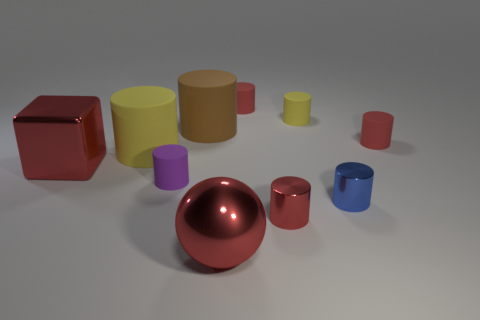How many red cylinders must be subtracted to get 1 red cylinders? 2 Subtract all blue spheres. How many red cylinders are left? 3 Subtract 2 cylinders. How many cylinders are left? 6 Subtract all brown cylinders. How many cylinders are left? 7 Subtract all red rubber cylinders. How many cylinders are left? 6 Subtract all brown cylinders. Subtract all purple spheres. How many cylinders are left? 7 Subtract all cylinders. How many objects are left? 2 Subtract 0 green cubes. How many objects are left? 10 Subtract all red matte things. Subtract all brown matte objects. How many objects are left? 7 Add 6 blue metallic cylinders. How many blue metallic cylinders are left? 7 